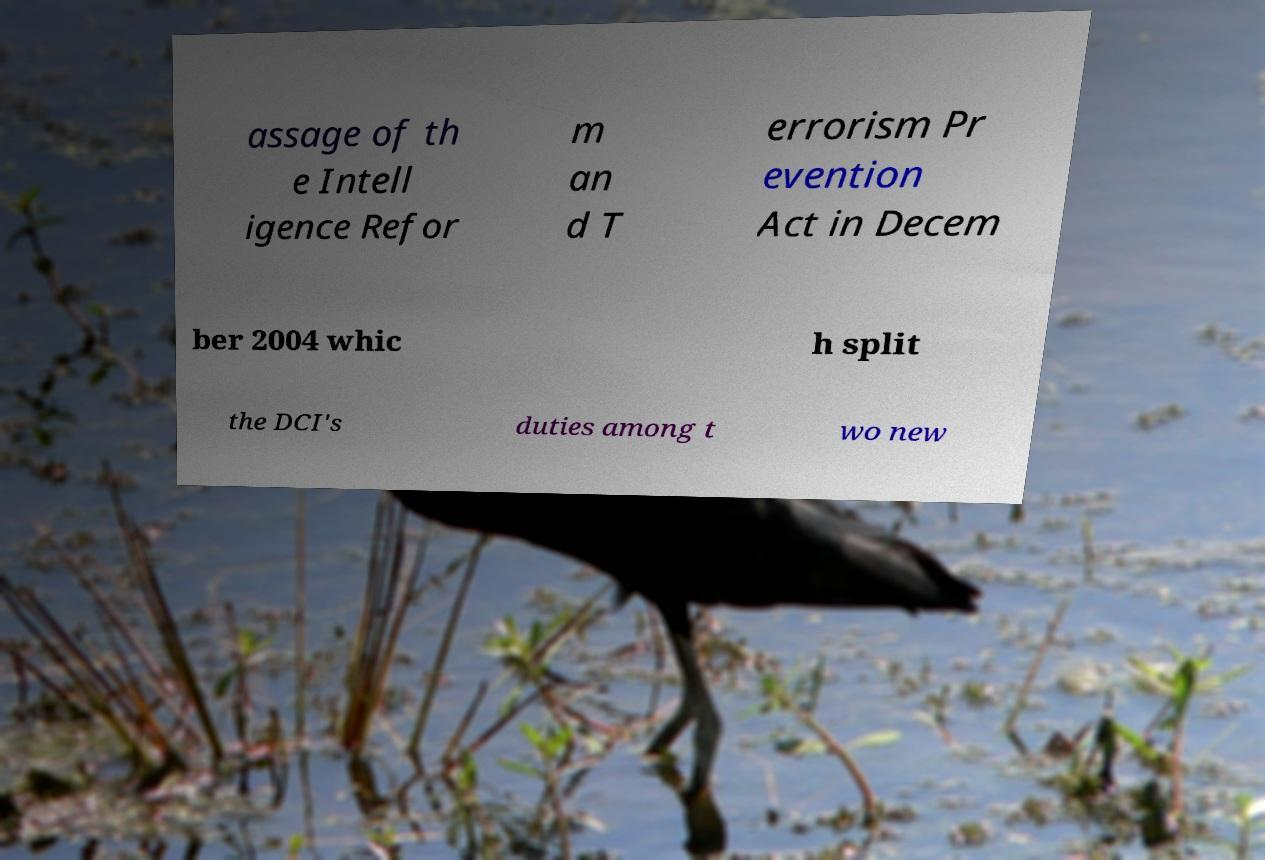Please read and relay the text visible in this image. What does it say? assage of th e Intell igence Refor m an d T errorism Pr evention Act in Decem ber 2004 whic h split the DCI's duties among t wo new 